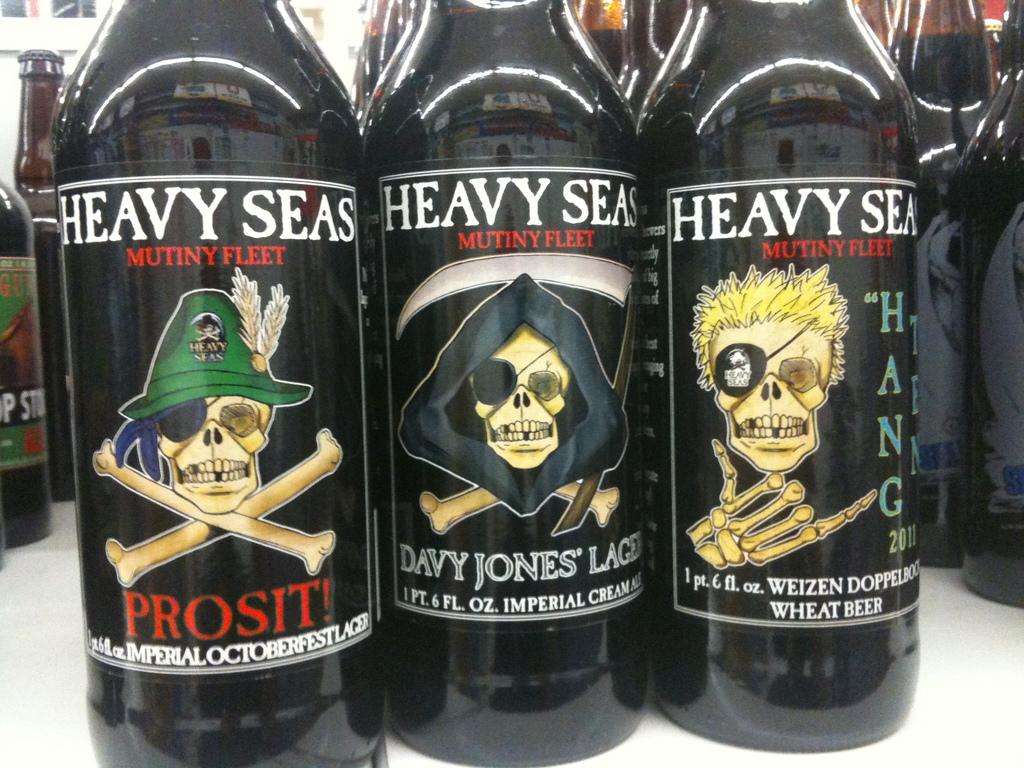What brand is the beer?
Your answer should be very brief. Heavy seas. 